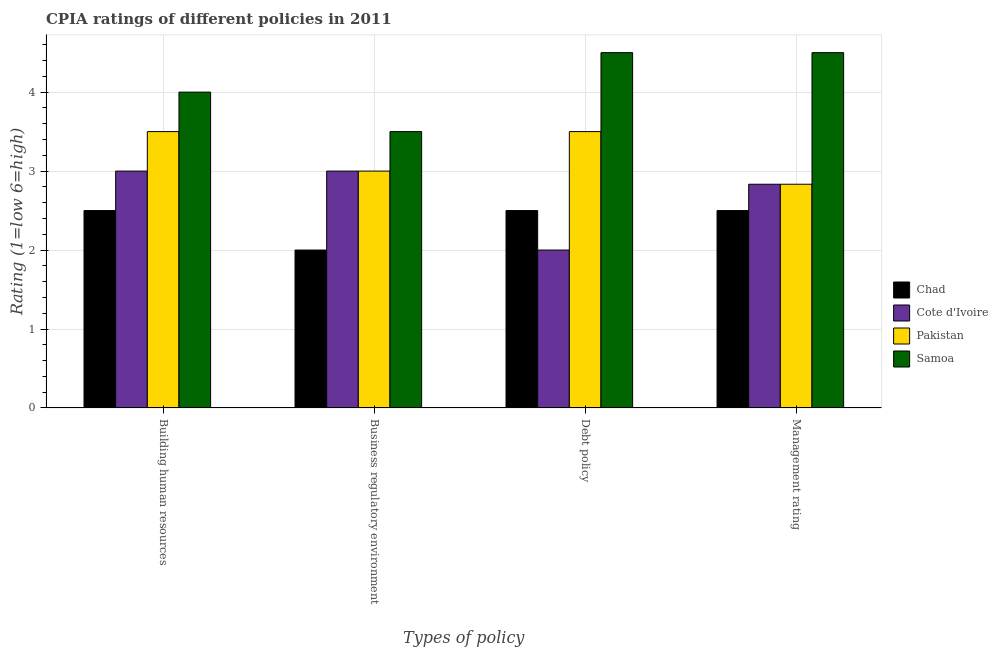How many groups of bars are there?
Make the answer very short. 4. Are the number of bars on each tick of the X-axis equal?
Offer a very short reply. Yes. How many bars are there on the 3rd tick from the left?
Make the answer very short. 4. How many bars are there on the 3rd tick from the right?
Offer a terse response. 4. What is the label of the 3rd group of bars from the left?
Ensure brevity in your answer.  Debt policy. What is the cpia rating of management in Samoa?
Provide a succinct answer. 4.5. Across all countries, what is the minimum cpia rating of debt policy?
Ensure brevity in your answer.  2. In which country was the cpia rating of management maximum?
Provide a short and direct response. Samoa. In which country was the cpia rating of management minimum?
Your answer should be very brief. Chad. What is the total cpia rating of management in the graph?
Provide a short and direct response. 12.67. What is the average cpia rating of management per country?
Keep it short and to the point. 3.17. In how many countries, is the cpia rating of building human resources greater than 3.8 ?
Your answer should be very brief. 1. What is the ratio of the cpia rating of debt policy in Chad to that in Cote d'Ivoire?
Your answer should be very brief. 1.25. What is the difference between the highest and the second highest cpia rating of debt policy?
Offer a terse response. 1. Is the sum of the cpia rating of debt policy in Cote d'Ivoire and Samoa greater than the maximum cpia rating of building human resources across all countries?
Make the answer very short. Yes. Is it the case that in every country, the sum of the cpia rating of building human resources and cpia rating of debt policy is greater than the sum of cpia rating of management and cpia rating of business regulatory environment?
Give a very brief answer. No. What does the 2nd bar from the left in Debt policy represents?
Offer a very short reply. Cote d'Ivoire. What does the 4th bar from the right in Debt policy represents?
Make the answer very short. Chad. What is the difference between two consecutive major ticks on the Y-axis?
Give a very brief answer. 1. Are the values on the major ticks of Y-axis written in scientific E-notation?
Your answer should be compact. No. Does the graph contain any zero values?
Give a very brief answer. No. Does the graph contain grids?
Your answer should be compact. Yes. How many legend labels are there?
Offer a very short reply. 4. How are the legend labels stacked?
Your response must be concise. Vertical. What is the title of the graph?
Offer a very short reply. CPIA ratings of different policies in 2011. Does "Middle East & North Africa (developing only)" appear as one of the legend labels in the graph?
Ensure brevity in your answer.  No. What is the label or title of the X-axis?
Provide a short and direct response. Types of policy. What is the label or title of the Y-axis?
Give a very brief answer. Rating (1=low 6=high). What is the Rating (1=low 6=high) of Chad in Building human resources?
Your answer should be very brief. 2.5. What is the Rating (1=low 6=high) of Pakistan in Building human resources?
Your answer should be compact. 3.5. What is the Rating (1=low 6=high) in Samoa in Building human resources?
Your response must be concise. 4. What is the Rating (1=low 6=high) in Cote d'Ivoire in Debt policy?
Offer a terse response. 2. What is the Rating (1=low 6=high) in Pakistan in Debt policy?
Provide a succinct answer. 3.5. What is the Rating (1=low 6=high) in Cote d'Ivoire in Management rating?
Ensure brevity in your answer.  2.83. What is the Rating (1=low 6=high) of Pakistan in Management rating?
Keep it short and to the point. 2.83. What is the Rating (1=low 6=high) in Samoa in Management rating?
Offer a very short reply. 4.5. Across all Types of policy, what is the maximum Rating (1=low 6=high) of Cote d'Ivoire?
Provide a succinct answer. 3. Across all Types of policy, what is the maximum Rating (1=low 6=high) of Pakistan?
Keep it short and to the point. 3.5. Across all Types of policy, what is the minimum Rating (1=low 6=high) of Chad?
Provide a succinct answer. 2. Across all Types of policy, what is the minimum Rating (1=low 6=high) of Cote d'Ivoire?
Ensure brevity in your answer.  2. Across all Types of policy, what is the minimum Rating (1=low 6=high) in Pakistan?
Your answer should be compact. 2.83. What is the total Rating (1=low 6=high) in Cote d'Ivoire in the graph?
Provide a succinct answer. 10.83. What is the total Rating (1=low 6=high) of Pakistan in the graph?
Keep it short and to the point. 12.83. What is the total Rating (1=low 6=high) of Samoa in the graph?
Your answer should be very brief. 16.5. What is the difference between the Rating (1=low 6=high) in Chad in Building human resources and that in Business regulatory environment?
Your answer should be compact. 0.5. What is the difference between the Rating (1=low 6=high) in Cote d'Ivoire in Building human resources and that in Business regulatory environment?
Keep it short and to the point. 0. What is the difference between the Rating (1=low 6=high) in Samoa in Building human resources and that in Business regulatory environment?
Provide a short and direct response. 0.5. What is the difference between the Rating (1=low 6=high) of Samoa in Building human resources and that in Debt policy?
Offer a very short reply. -0.5. What is the difference between the Rating (1=low 6=high) of Chad in Building human resources and that in Management rating?
Your response must be concise. 0. What is the difference between the Rating (1=low 6=high) in Cote d'Ivoire in Building human resources and that in Management rating?
Ensure brevity in your answer.  0.17. What is the difference between the Rating (1=low 6=high) in Chad in Business regulatory environment and that in Debt policy?
Ensure brevity in your answer.  -0.5. What is the difference between the Rating (1=low 6=high) of Samoa in Business regulatory environment and that in Management rating?
Keep it short and to the point. -1. What is the difference between the Rating (1=low 6=high) in Chad in Debt policy and that in Management rating?
Your answer should be compact. 0. What is the difference between the Rating (1=low 6=high) in Pakistan in Debt policy and that in Management rating?
Give a very brief answer. 0.67. What is the difference between the Rating (1=low 6=high) in Chad in Building human resources and the Rating (1=low 6=high) in Cote d'Ivoire in Business regulatory environment?
Offer a terse response. -0.5. What is the difference between the Rating (1=low 6=high) of Chad in Building human resources and the Rating (1=low 6=high) of Pakistan in Business regulatory environment?
Your answer should be very brief. -0.5. What is the difference between the Rating (1=low 6=high) of Chad in Building human resources and the Rating (1=low 6=high) of Samoa in Business regulatory environment?
Give a very brief answer. -1. What is the difference between the Rating (1=low 6=high) of Cote d'Ivoire in Building human resources and the Rating (1=low 6=high) of Samoa in Business regulatory environment?
Give a very brief answer. -0.5. What is the difference between the Rating (1=low 6=high) in Chad in Building human resources and the Rating (1=low 6=high) in Cote d'Ivoire in Debt policy?
Provide a succinct answer. 0.5. What is the difference between the Rating (1=low 6=high) in Chad in Building human resources and the Rating (1=low 6=high) in Pakistan in Debt policy?
Your answer should be compact. -1. What is the difference between the Rating (1=low 6=high) of Chad in Building human resources and the Rating (1=low 6=high) of Samoa in Debt policy?
Offer a very short reply. -2. What is the difference between the Rating (1=low 6=high) of Cote d'Ivoire in Building human resources and the Rating (1=low 6=high) of Samoa in Debt policy?
Make the answer very short. -1.5. What is the difference between the Rating (1=low 6=high) in Chad in Building human resources and the Rating (1=low 6=high) in Cote d'Ivoire in Management rating?
Your answer should be compact. -0.33. What is the difference between the Rating (1=low 6=high) of Chad in Building human resources and the Rating (1=low 6=high) of Pakistan in Management rating?
Ensure brevity in your answer.  -0.33. What is the difference between the Rating (1=low 6=high) in Cote d'Ivoire in Building human resources and the Rating (1=low 6=high) in Pakistan in Management rating?
Keep it short and to the point. 0.17. What is the difference between the Rating (1=low 6=high) of Chad in Business regulatory environment and the Rating (1=low 6=high) of Cote d'Ivoire in Debt policy?
Your response must be concise. 0. What is the difference between the Rating (1=low 6=high) of Chad in Business regulatory environment and the Rating (1=low 6=high) of Pakistan in Debt policy?
Your answer should be compact. -1.5. What is the difference between the Rating (1=low 6=high) in Chad in Business regulatory environment and the Rating (1=low 6=high) in Samoa in Debt policy?
Your answer should be very brief. -2.5. What is the difference between the Rating (1=low 6=high) of Cote d'Ivoire in Business regulatory environment and the Rating (1=low 6=high) of Samoa in Management rating?
Ensure brevity in your answer.  -1.5. What is the difference between the Rating (1=low 6=high) in Chad in Debt policy and the Rating (1=low 6=high) in Cote d'Ivoire in Management rating?
Your answer should be compact. -0.33. What is the difference between the Rating (1=low 6=high) of Chad in Debt policy and the Rating (1=low 6=high) of Samoa in Management rating?
Give a very brief answer. -2. What is the difference between the Rating (1=low 6=high) of Cote d'Ivoire in Debt policy and the Rating (1=low 6=high) of Samoa in Management rating?
Provide a short and direct response. -2.5. What is the average Rating (1=low 6=high) in Chad per Types of policy?
Your answer should be compact. 2.38. What is the average Rating (1=low 6=high) of Cote d'Ivoire per Types of policy?
Keep it short and to the point. 2.71. What is the average Rating (1=low 6=high) in Pakistan per Types of policy?
Offer a very short reply. 3.21. What is the average Rating (1=low 6=high) in Samoa per Types of policy?
Offer a very short reply. 4.12. What is the difference between the Rating (1=low 6=high) of Chad and Rating (1=low 6=high) of Pakistan in Building human resources?
Ensure brevity in your answer.  -1. What is the difference between the Rating (1=low 6=high) in Cote d'Ivoire and Rating (1=low 6=high) in Pakistan in Building human resources?
Give a very brief answer. -0.5. What is the difference between the Rating (1=low 6=high) of Pakistan and Rating (1=low 6=high) of Samoa in Building human resources?
Your answer should be very brief. -0.5. What is the difference between the Rating (1=low 6=high) in Cote d'Ivoire and Rating (1=low 6=high) in Pakistan in Business regulatory environment?
Make the answer very short. 0. What is the difference between the Rating (1=low 6=high) in Cote d'Ivoire and Rating (1=low 6=high) in Samoa in Business regulatory environment?
Provide a succinct answer. -0.5. What is the difference between the Rating (1=low 6=high) of Chad and Rating (1=low 6=high) of Pakistan in Debt policy?
Provide a succinct answer. -1. What is the difference between the Rating (1=low 6=high) in Cote d'Ivoire and Rating (1=low 6=high) in Pakistan in Debt policy?
Provide a succinct answer. -1.5. What is the difference between the Rating (1=low 6=high) in Cote d'Ivoire and Rating (1=low 6=high) in Samoa in Debt policy?
Ensure brevity in your answer.  -2.5. What is the difference between the Rating (1=low 6=high) in Pakistan and Rating (1=low 6=high) in Samoa in Debt policy?
Make the answer very short. -1. What is the difference between the Rating (1=low 6=high) of Chad and Rating (1=low 6=high) of Pakistan in Management rating?
Keep it short and to the point. -0.33. What is the difference between the Rating (1=low 6=high) of Cote d'Ivoire and Rating (1=low 6=high) of Samoa in Management rating?
Your answer should be very brief. -1.67. What is the difference between the Rating (1=low 6=high) of Pakistan and Rating (1=low 6=high) of Samoa in Management rating?
Offer a terse response. -1.67. What is the ratio of the Rating (1=low 6=high) of Cote d'Ivoire in Building human resources to that in Business regulatory environment?
Keep it short and to the point. 1. What is the ratio of the Rating (1=low 6=high) of Cote d'Ivoire in Building human resources to that in Management rating?
Ensure brevity in your answer.  1.06. What is the ratio of the Rating (1=low 6=high) of Pakistan in Building human resources to that in Management rating?
Provide a short and direct response. 1.24. What is the ratio of the Rating (1=low 6=high) in Cote d'Ivoire in Business regulatory environment to that in Debt policy?
Your answer should be compact. 1.5. What is the ratio of the Rating (1=low 6=high) of Pakistan in Business regulatory environment to that in Debt policy?
Your response must be concise. 0.86. What is the ratio of the Rating (1=low 6=high) of Cote d'Ivoire in Business regulatory environment to that in Management rating?
Offer a terse response. 1.06. What is the ratio of the Rating (1=low 6=high) of Pakistan in Business regulatory environment to that in Management rating?
Keep it short and to the point. 1.06. What is the ratio of the Rating (1=low 6=high) of Samoa in Business regulatory environment to that in Management rating?
Your answer should be very brief. 0.78. What is the ratio of the Rating (1=low 6=high) of Cote d'Ivoire in Debt policy to that in Management rating?
Give a very brief answer. 0.71. What is the ratio of the Rating (1=low 6=high) of Pakistan in Debt policy to that in Management rating?
Ensure brevity in your answer.  1.24. What is the difference between the highest and the lowest Rating (1=low 6=high) in Chad?
Provide a succinct answer. 0.5. What is the difference between the highest and the lowest Rating (1=low 6=high) of Cote d'Ivoire?
Ensure brevity in your answer.  1. What is the difference between the highest and the lowest Rating (1=low 6=high) in Samoa?
Your response must be concise. 1. 